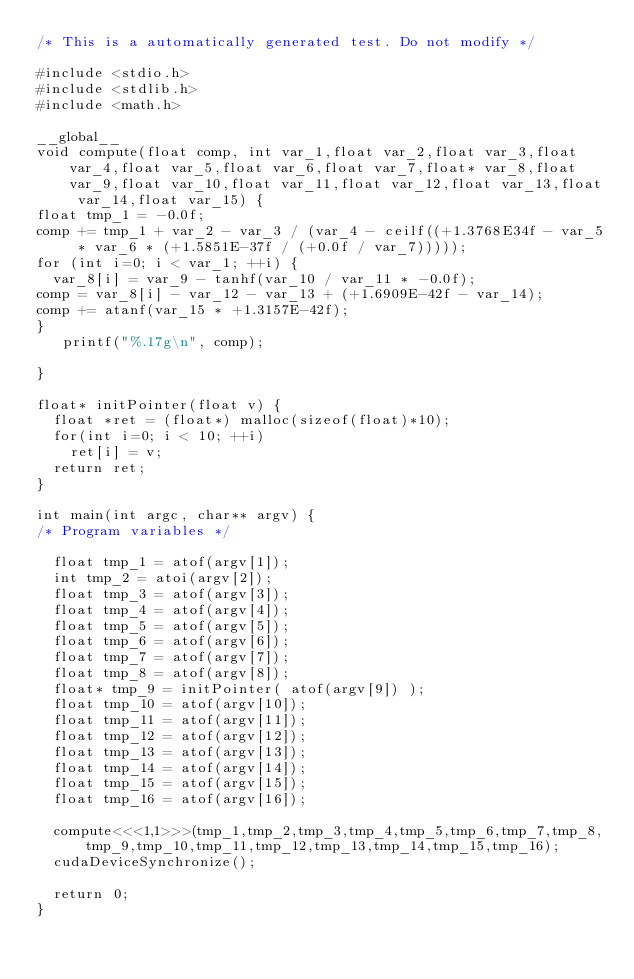Convert code to text. <code><loc_0><loc_0><loc_500><loc_500><_Cuda_>/* This is a automatically generated test. Do not modify */

#include <stdio.h>
#include <stdlib.h>
#include <math.h>

__global__
void compute(float comp, int var_1,float var_2,float var_3,float var_4,float var_5,float var_6,float var_7,float* var_8,float var_9,float var_10,float var_11,float var_12,float var_13,float var_14,float var_15) {
float tmp_1 = -0.0f;
comp += tmp_1 + var_2 - var_3 / (var_4 - ceilf((+1.3768E34f - var_5 * var_6 * (+1.5851E-37f / (+0.0f / var_7)))));
for (int i=0; i < var_1; ++i) {
  var_8[i] = var_9 - tanhf(var_10 / var_11 * -0.0f);
comp = var_8[i] - var_12 - var_13 + (+1.6909E-42f - var_14);
comp += atanf(var_15 * +1.3157E-42f);
}
   printf("%.17g\n", comp);

}

float* initPointer(float v) {
  float *ret = (float*) malloc(sizeof(float)*10);
  for(int i=0; i < 10; ++i)
    ret[i] = v;
  return ret;
}

int main(int argc, char** argv) {
/* Program variables */

  float tmp_1 = atof(argv[1]);
  int tmp_2 = atoi(argv[2]);
  float tmp_3 = atof(argv[3]);
  float tmp_4 = atof(argv[4]);
  float tmp_5 = atof(argv[5]);
  float tmp_6 = atof(argv[6]);
  float tmp_7 = atof(argv[7]);
  float tmp_8 = atof(argv[8]);
  float* tmp_9 = initPointer( atof(argv[9]) );
  float tmp_10 = atof(argv[10]);
  float tmp_11 = atof(argv[11]);
  float tmp_12 = atof(argv[12]);
  float tmp_13 = atof(argv[13]);
  float tmp_14 = atof(argv[14]);
  float tmp_15 = atof(argv[15]);
  float tmp_16 = atof(argv[16]);

  compute<<<1,1>>>(tmp_1,tmp_2,tmp_3,tmp_4,tmp_5,tmp_6,tmp_7,tmp_8,tmp_9,tmp_10,tmp_11,tmp_12,tmp_13,tmp_14,tmp_15,tmp_16);
  cudaDeviceSynchronize();

  return 0;
}
</code> 